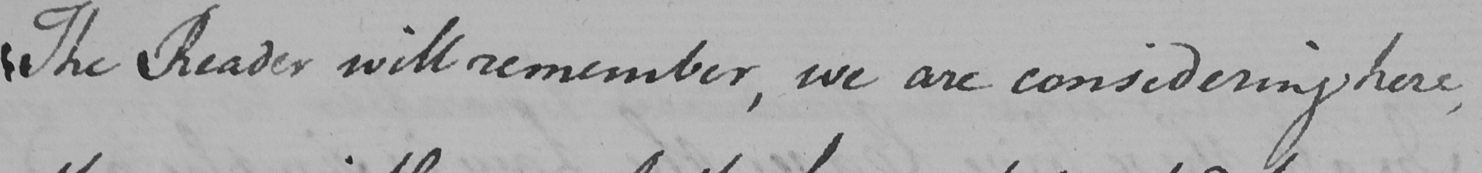What is written in this line of handwriting? The Reader will remember , we are considering here , 